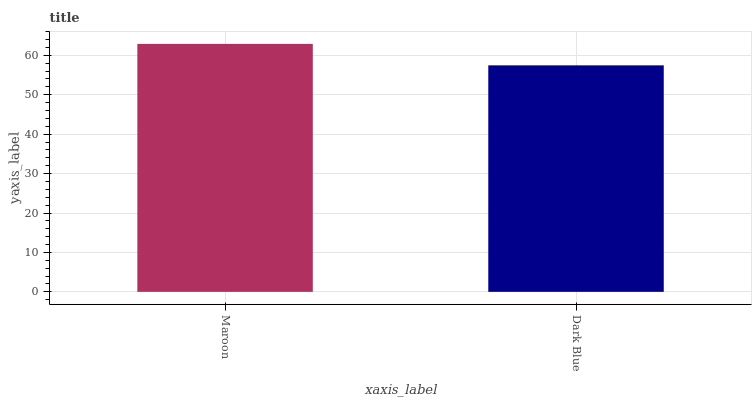Is Dark Blue the minimum?
Answer yes or no. Yes. Is Maroon the maximum?
Answer yes or no. Yes. Is Dark Blue the maximum?
Answer yes or no. No. Is Maroon greater than Dark Blue?
Answer yes or no. Yes. Is Dark Blue less than Maroon?
Answer yes or no. Yes. Is Dark Blue greater than Maroon?
Answer yes or no. No. Is Maroon less than Dark Blue?
Answer yes or no. No. Is Maroon the high median?
Answer yes or no. Yes. Is Dark Blue the low median?
Answer yes or no. Yes. Is Dark Blue the high median?
Answer yes or no. No. Is Maroon the low median?
Answer yes or no. No. 